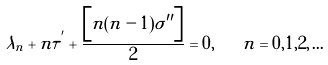<formula> <loc_0><loc_0><loc_500><loc_500>\lambda _ { n } + n \tau ^ { ^ { \prime } } + \frac { \left [ n ( n - 1 ) \sigma ^ { \prime \prime } \right ] } { 2 } = 0 , \quad n = 0 , 1 , 2 , \dots</formula> 